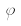<formula> <loc_0><loc_0><loc_500><loc_500>\varphi</formula> 